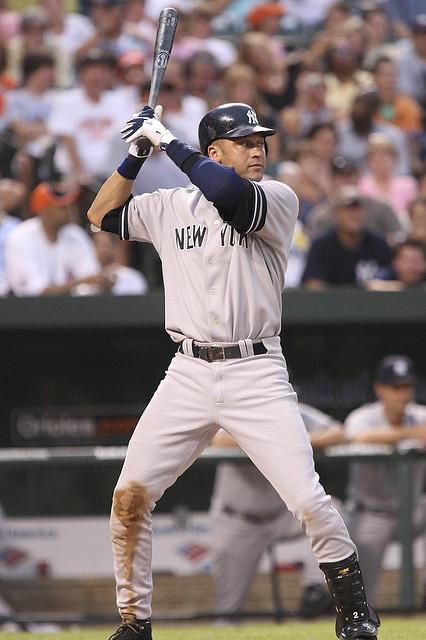What is he holding?
Write a very short answer. Bat. Who is this?
Answer briefly. Baseball player. Does he play for New York?
Give a very brief answer. Yes. 